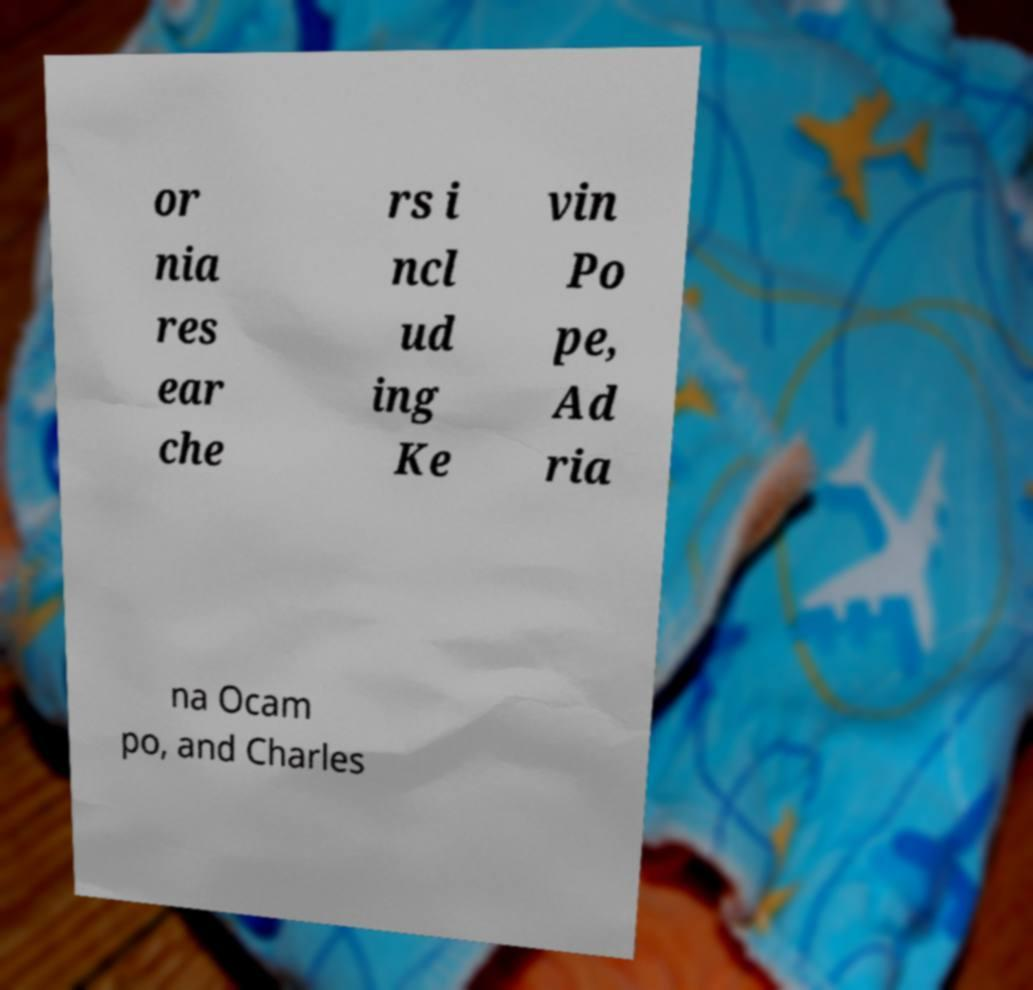What messages or text are displayed in this image? I need them in a readable, typed format. or nia res ear che rs i ncl ud ing Ke vin Po pe, Ad ria na Ocam po, and Charles 